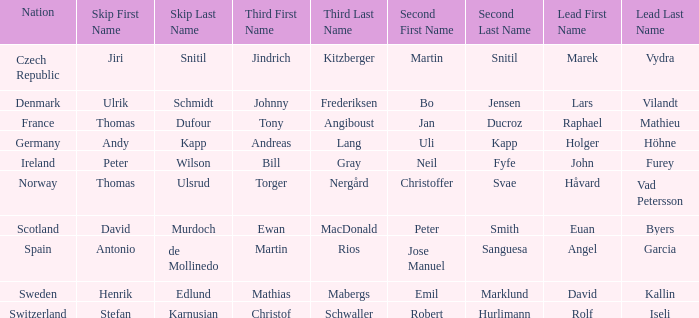When did France come in second? Jan Ducroz. Parse the full table. {'header': ['Nation', 'Skip First Name', 'Skip Last Name', 'Third First Name', 'Third Last Name', 'Second First Name', 'Second Last Name', 'Lead First Name', 'Lead Last Name'], 'rows': [['Czech Republic', 'Jiri', 'Snitil', 'Jindrich', 'Kitzberger', 'Martin', 'Snitil', 'Marek', 'Vydra'], ['Denmark', 'Ulrik', 'Schmidt', 'Johnny', 'Frederiksen', 'Bo', 'Jensen', 'Lars', 'Vilandt'], ['France', 'Thomas', 'Dufour', 'Tony', 'Angiboust', 'Jan', 'Ducroz', 'Raphael', 'Mathieu'], ['Germany', 'Andy', 'Kapp', 'Andreas', 'Lang', 'Uli', 'Kapp', 'Holger', 'Höhne'], ['Ireland', 'Peter', 'Wilson', 'Bill', 'Gray', 'Neil', 'Fyfe', 'John', 'Furey'], ['Norway', 'Thomas', 'Ulsrud', 'Torger', 'Nergård', 'Christoffer', 'Svae', 'Håvard', 'Vad Petersson'], ['Scotland', 'David', 'Murdoch', 'Ewan', 'MacDonald', 'Peter', 'Smith', 'Euan', 'Byers'], ['Spain', 'Antonio', 'de Mollinedo', 'Martin', 'Rios', 'Jose Manuel', 'Sanguesa', 'Angel', 'Garcia'], ['Sweden', 'Henrik', 'Edlund', 'Mathias', 'Mabergs', 'Emil', 'Marklund', 'David', 'Kallin'], ['Switzerland', 'Stefan', 'Karnusian', 'Christof', 'Schwaller', 'Robert', 'Hurlimann', 'Rolf', 'Iseli']]} 